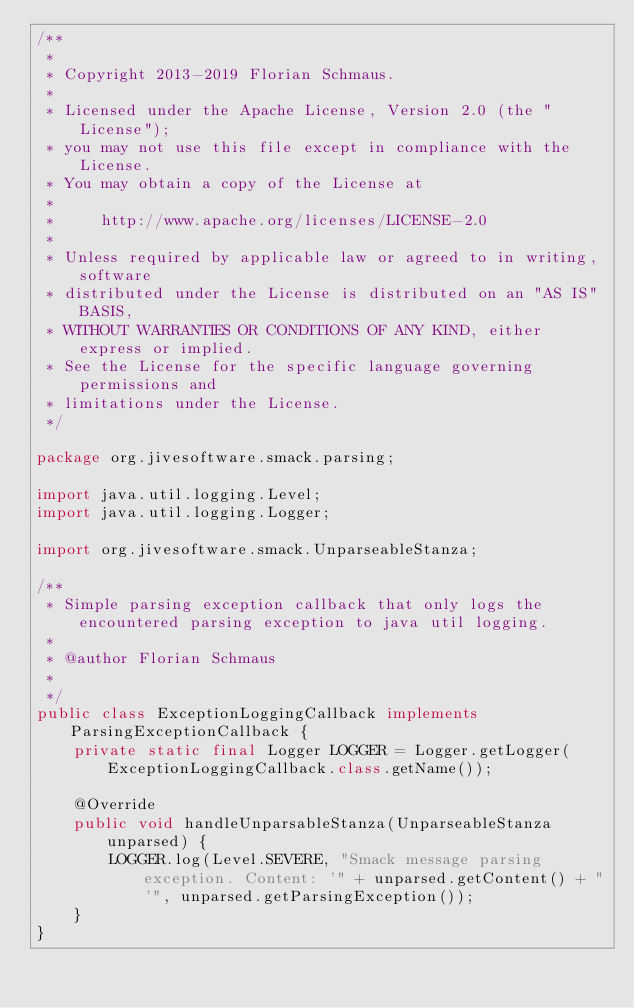Convert code to text. <code><loc_0><loc_0><loc_500><loc_500><_Java_>/**
 *
 * Copyright 2013-2019 Florian Schmaus.
 *
 * Licensed under the Apache License, Version 2.0 (the "License");
 * you may not use this file except in compliance with the License.
 * You may obtain a copy of the License at
 *
 *     http://www.apache.org/licenses/LICENSE-2.0
 *
 * Unless required by applicable law or agreed to in writing, software
 * distributed under the License is distributed on an "AS IS" BASIS,
 * WITHOUT WARRANTIES OR CONDITIONS OF ANY KIND, either express or implied.
 * See the License for the specific language governing permissions and
 * limitations under the License.
 */

package org.jivesoftware.smack.parsing;

import java.util.logging.Level;
import java.util.logging.Logger;

import org.jivesoftware.smack.UnparseableStanza;

/**
 * Simple parsing exception callback that only logs the encountered parsing exception to java util logging.
 *
 * @author Florian Schmaus
 *
 */
public class ExceptionLoggingCallback implements ParsingExceptionCallback {
    private static final Logger LOGGER = Logger.getLogger(ExceptionLoggingCallback.class.getName());

    @Override
    public void handleUnparsableStanza(UnparseableStanza unparsed) {
        LOGGER.log(Level.SEVERE, "Smack message parsing exception. Content: '" + unparsed.getContent() + "'", unparsed.getParsingException());
    }
}
</code> 